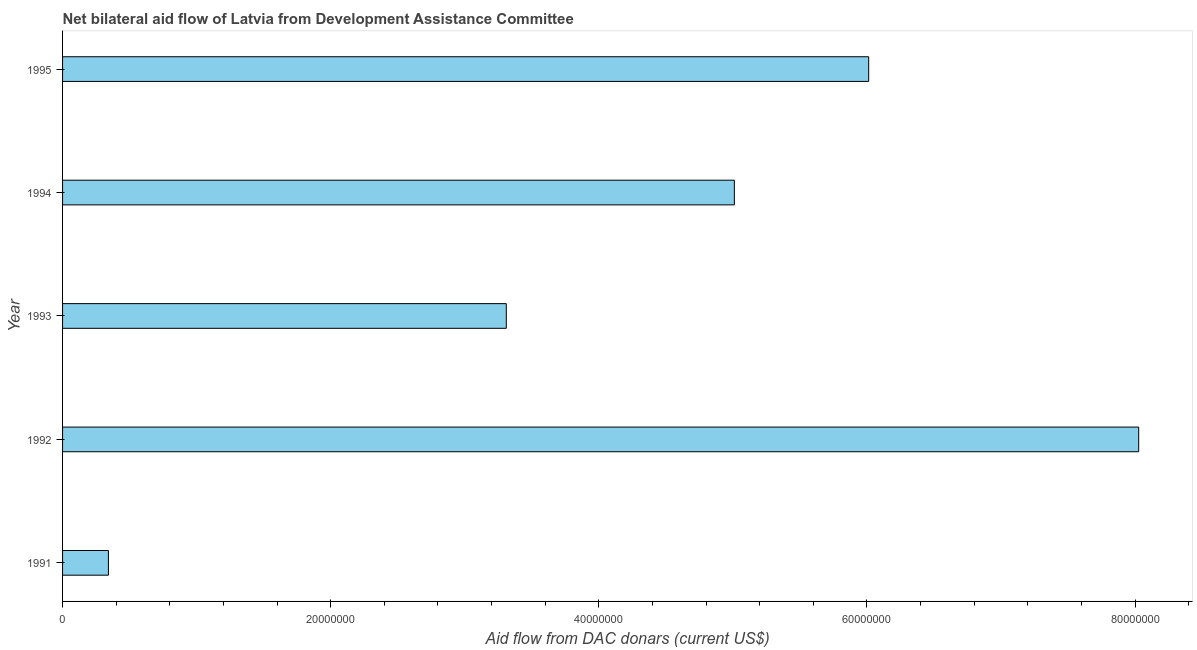What is the title of the graph?
Your answer should be very brief. Net bilateral aid flow of Latvia from Development Assistance Committee. What is the label or title of the X-axis?
Offer a terse response. Aid flow from DAC donars (current US$). What is the label or title of the Y-axis?
Your answer should be very brief. Year. What is the net bilateral aid flows from dac donors in 1995?
Provide a short and direct response. 6.01e+07. Across all years, what is the maximum net bilateral aid flows from dac donors?
Provide a succinct answer. 8.03e+07. Across all years, what is the minimum net bilateral aid flows from dac donors?
Your answer should be compact. 3.42e+06. In which year was the net bilateral aid flows from dac donors minimum?
Give a very brief answer. 1991. What is the sum of the net bilateral aid flows from dac donors?
Offer a terse response. 2.27e+08. What is the difference between the net bilateral aid flows from dac donors in 1992 and 1995?
Give a very brief answer. 2.01e+07. What is the average net bilateral aid flows from dac donors per year?
Keep it short and to the point. 4.54e+07. What is the median net bilateral aid flows from dac donors?
Ensure brevity in your answer.  5.01e+07. In how many years, is the net bilateral aid flows from dac donors greater than 12000000 US$?
Offer a very short reply. 4. Do a majority of the years between 1995 and 1994 (inclusive) have net bilateral aid flows from dac donors greater than 60000000 US$?
Ensure brevity in your answer.  No. What is the ratio of the net bilateral aid flows from dac donors in 1991 to that in 1994?
Ensure brevity in your answer.  0.07. Is the net bilateral aid flows from dac donors in 1992 less than that in 1993?
Your response must be concise. No. Is the difference between the net bilateral aid flows from dac donors in 1991 and 1995 greater than the difference between any two years?
Ensure brevity in your answer.  No. What is the difference between the highest and the second highest net bilateral aid flows from dac donors?
Your answer should be very brief. 2.01e+07. What is the difference between the highest and the lowest net bilateral aid flows from dac donors?
Keep it short and to the point. 7.68e+07. In how many years, is the net bilateral aid flows from dac donors greater than the average net bilateral aid flows from dac donors taken over all years?
Your answer should be very brief. 3. How many bars are there?
Give a very brief answer. 5. Are all the bars in the graph horizontal?
Your answer should be very brief. Yes. Are the values on the major ticks of X-axis written in scientific E-notation?
Your answer should be very brief. No. What is the Aid flow from DAC donars (current US$) in 1991?
Provide a succinct answer. 3.42e+06. What is the Aid flow from DAC donars (current US$) of 1992?
Ensure brevity in your answer.  8.03e+07. What is the Aid flow from DAC donars (current US$) in 1993?
Offer a very short reply. 3.31e+07. What is the Aid flow from DAC donars (current US$) in 1994?
Your answer should be very brief. 5.01e+07. What is the Aid flow from DAC donars (current US$) in 1995?
Offer a very short reply. 6.01e+07. What is the difference between the Aid flow from DAC donars (current US$) in 1991 and 1992?
Offer a very short reply. -7.68e+07. What is the difference between the Aid flow from DAC donars (current US$) in 1991 and 1993?
Keep it short and to the point. -2.97e+07. What is the difference between the Aid flow from DAC donars (current US$) in 1991 and 1994?
Ensure brevity in your answer.  -4.67e+07. What is the difference between the Aid flow from DAC donars (current US$) in 1991 and 1995?
Your response must be concise. -5.67e+07. What is the difference between the Aid flow from DAC donars (current US$) in 1992 and 1993?
Make the answer very short. 4.72e+07. What is the difference between the Aid flow from DAC donars (current US$) in 1992 and 1994?
Your answer should be very brief. 3.02e+07. What is the difference between the Aid flow from DAC donars (current US$) in 1992 and 1995?
Offer a terse response. 2.01e+07. What is the difference between the Aid flow from DAC donars (current US$) in 1993 and 1994?
Provide a short and direct response. -1.70e+07. What is the difference between the Aid flow from DAC donars (current US$) in 1993 and 1995?
Make the answer very short. -2.70e+07. What is the difference between the Aid flow from DAC donars (current US$) in 1994 and 1995?
Make the answer very short. -1.00e+07. What is the ratio of the Aid flow from DAC donars (current US$) in 1991 to that in 1992?
Offer a very short reply. 0.04. What is the ratio of the Aid flow from DAC donars (current US$) in 1991 to that in 1993?
Provide a succinct answer. 0.1. What is the ratio of the Aid flow from DAC donars (current US$) in 1991 to that in 1994?
Your answer should be very brief. 0.07. What is the ratio of the Aid flow from DAC donars (current US$) in 1991 to that in 1995?
Your answer should be compact. 0.06. What is the ratio of the Aid flow from DAC donars (current US$) in 1992 to that in 1993?
Keep it short and to the point. 2.42. What is the ratio of the Aid flow from DAC donars (current US$) in 1992 to that in 1994?
Your answer should be compact. 1.6. What is the ratio of the Aid flow from DAC donars (current US$) in 1992 to that in 1995?
Make the answer very short. 1.33. What is the ratio of the Aid flow from DAC donars (current US$) in 1993 to that in 1994?
Give a very brief answer. 0.66. What is the ratio of the Aid flow from DAC donars (current US$) in 1993 to that in 1995?
Offer a very short reply. 0.55. What is the ratio of the Aid flow from DAC donars (current US$) in 1994 to that in 1995?
Give a very brief answer. 0.83. 